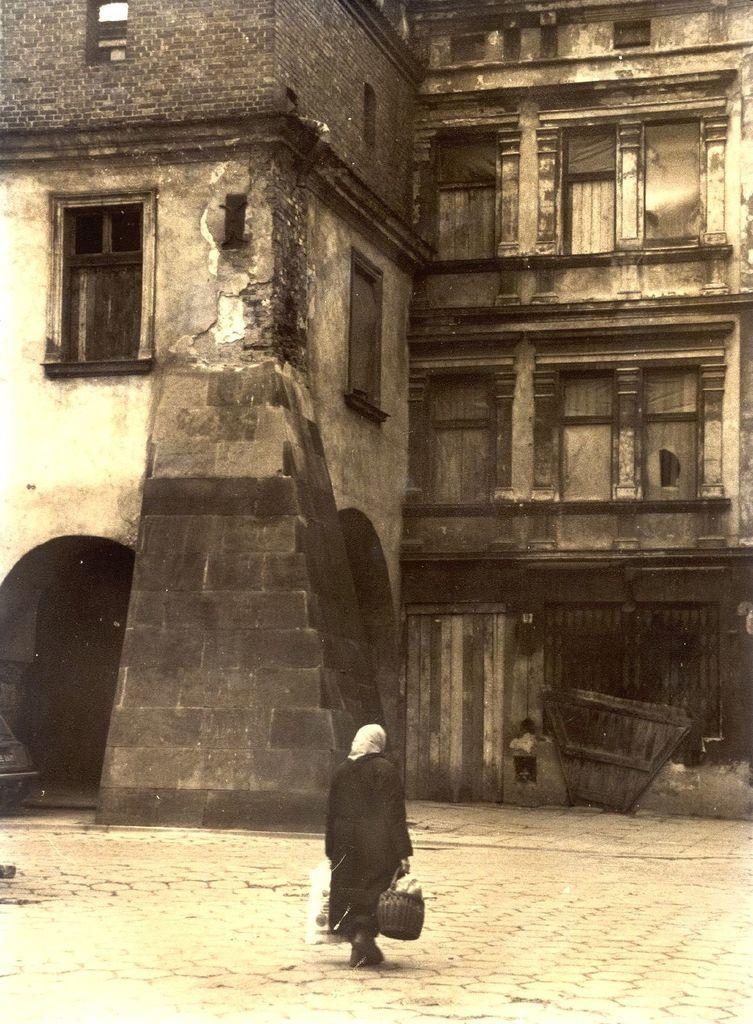In one or two sentences, can you explain what this image depicts? It is the black and white image in which there is a person walking on the floor by holding the bag with one hand and a cover with another hand. In front of him there is an old building. On the left side there is a window. 